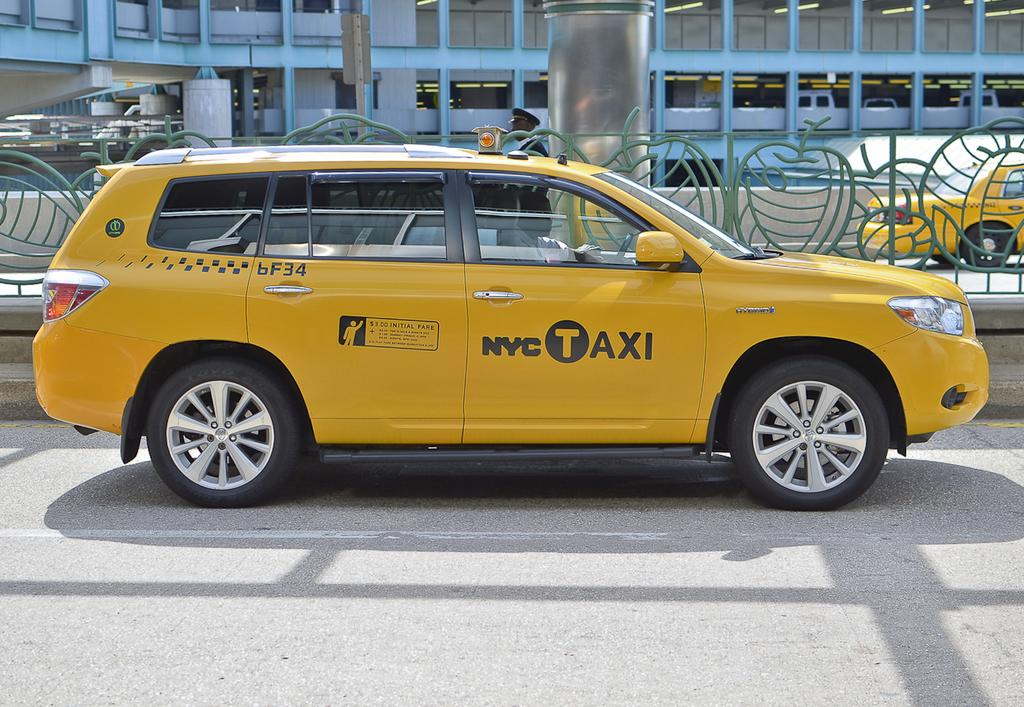<image>
Write a terse but informative summary of the picture. A yellow NYC Taxi drives down the street. 